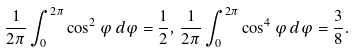Convert formula to latex. <formula><loc_0><loc_0><loc_500><loc_500>\frac { 1 } { 2 \pi } \int _ { 0 } ^ { 2 \pi } \cos ^ { 2 } \varphi \, d \varphi = \frac { 1 } { 2 } , \, \frac { 1 } { 2 \pi } \int _ { 0 } ^ { 2 \pi } \cos ^ { 4 } \varphi \, d \varphi = \frac { 3 } { 8 } .</formula> 